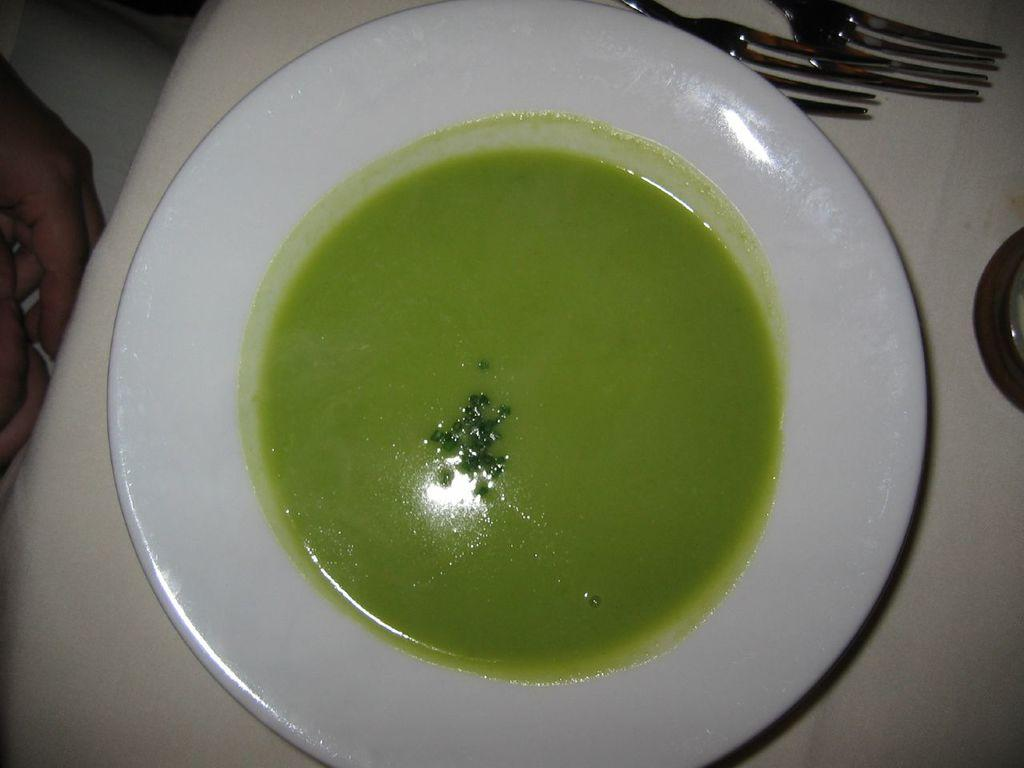What is on the plate in the image? There is a plate with liquid substances (soup) in the image. What utensils can be seen in the image? There are forks visible in the image. What body parts are present in the image? Human hands are present in the image. What type of corn can be seen growing in the image? There is no corn present in the image. What is the color of the sky in the image? The sky is not visible in the image. What occupation might be associated with the person in the image? There is no person or occupation mentioned in the image. 